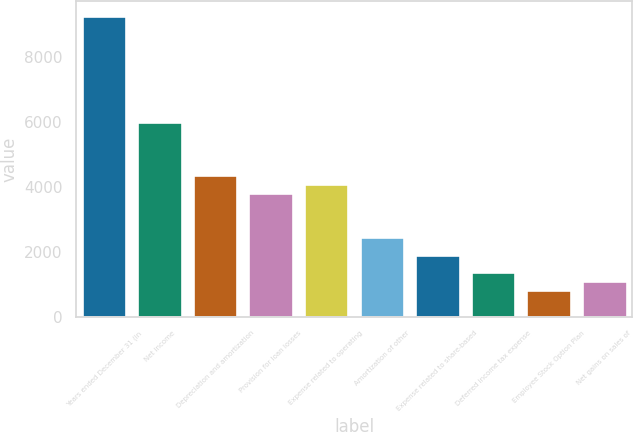Convert chart to OTSL. <chart><loc_0><loc_0><loc_500><loc_500><bar_chart><fcel>Years ended December 31 (in<fcel>Net income<fcel>Depreciation and amortization<fcel>Provision for loan losses<fcel>Expense related to operating<fcel>Amortization of other<fcel>Expense related to share-based<fcel>Deferred income tax expense<fcel>Employee Stock Option Plan<fcel>Net gains on sales of<nl><fcel>9246.58<fcel>5983.54<fcel>4352.02<fcel>3808.18<fcel>4080.1<fcel>2448.58<fcel>1904.74<fcel>1360.9<fcel>817.06<fcel>1088.98<nl></chart> 